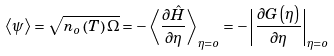<formula> <loc_0><loc_0><loc_500><loc_500>\left \langle \psi \right \rangle = \sqrt { n _ { o } \left ( T \right ) \Omega } = - \left \langle \frac { \partial \hat { H } } { \partial \eta } \right \rangle _ { \eta = o } = - \left | \frac { \partial G \left ( \eta \right ) } { \partial \eta } \right | _ { \eta = o }</formula> 